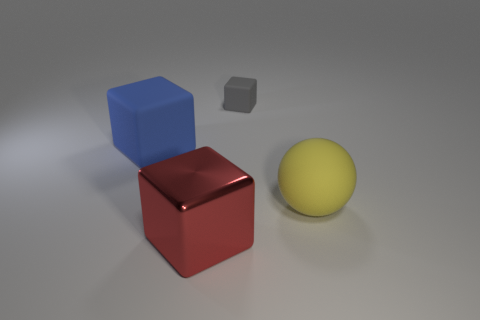Is there any other thing that is the same shape as the gray matte object? Yes, the red glossy object in the image has the same cubic shape as the gray matte object, but it differs in color and surface finish. 